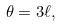<formula> <loc_0><loc_0><loc_500><loc_500>\theta = 3 \ell ,</formula> 